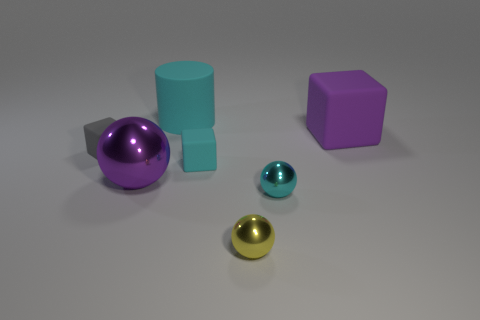Subtract all green spheres. Subtract all gray cylinders. How many spheres are left? 3 Add 3 tiny cubes. How many objects exist? 10 Subtract all cylinders. How many objects are left? 6 Add 7 big matte cylinders. How many big matte cylinders are left? 8 Add 6 tiny metallic things. How many tiny metallic things exist? 8 Subtract 0 blue cylinders. How many objects are left? 7 Subtract all cyan rubber objects. Subtract all cyan matte blocks. How many objects are left? 4 